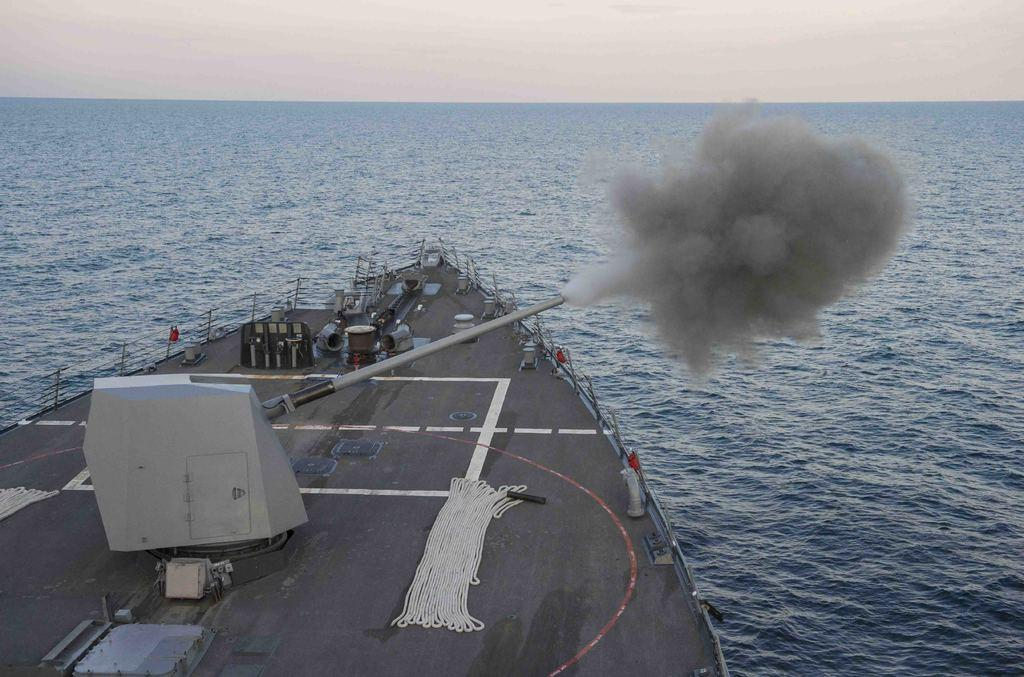What is the main subject of the image? There is a ship in the water. What can be seen on the ship? There is a metal pipe on the ship. What is the metal pipe doing? The metal pipe is releasing smoke. How would you describe the sky in the image? The sky is cloudy. What caption would you add to the image to describe the ship's journey? There is no caption present in the image, so it's not possible to determine what caption might be added. 